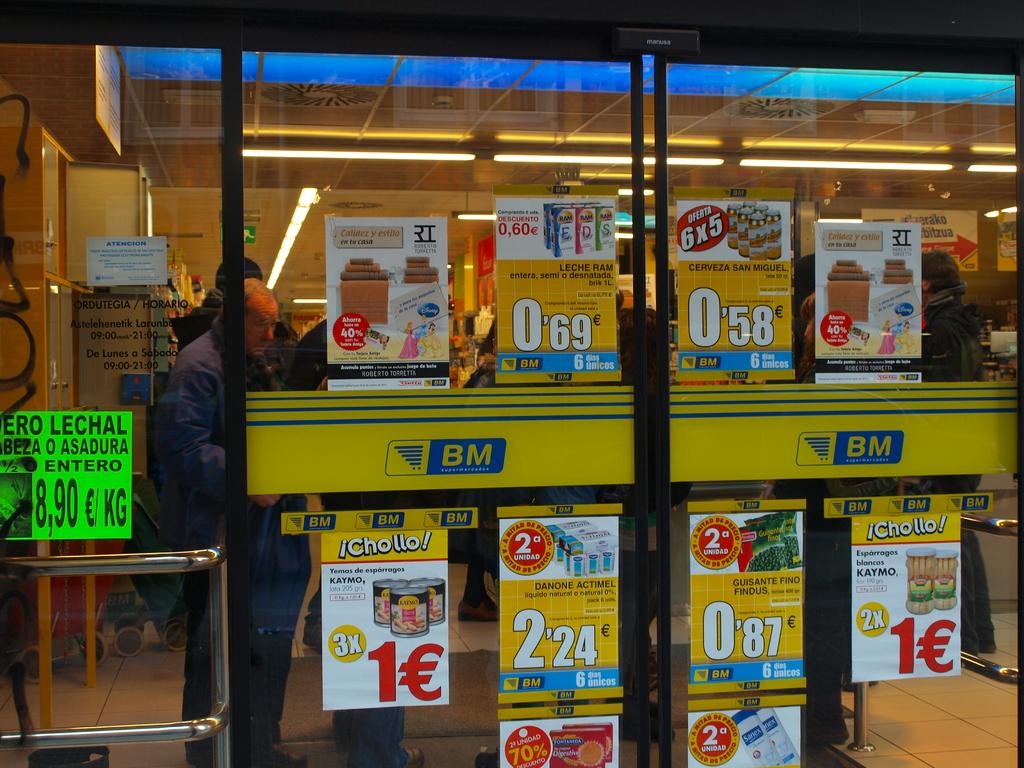What store is this the doors to?
Provide a succinct answer. Bm. How much is the chollo?
Give a very brief answer. 1. 